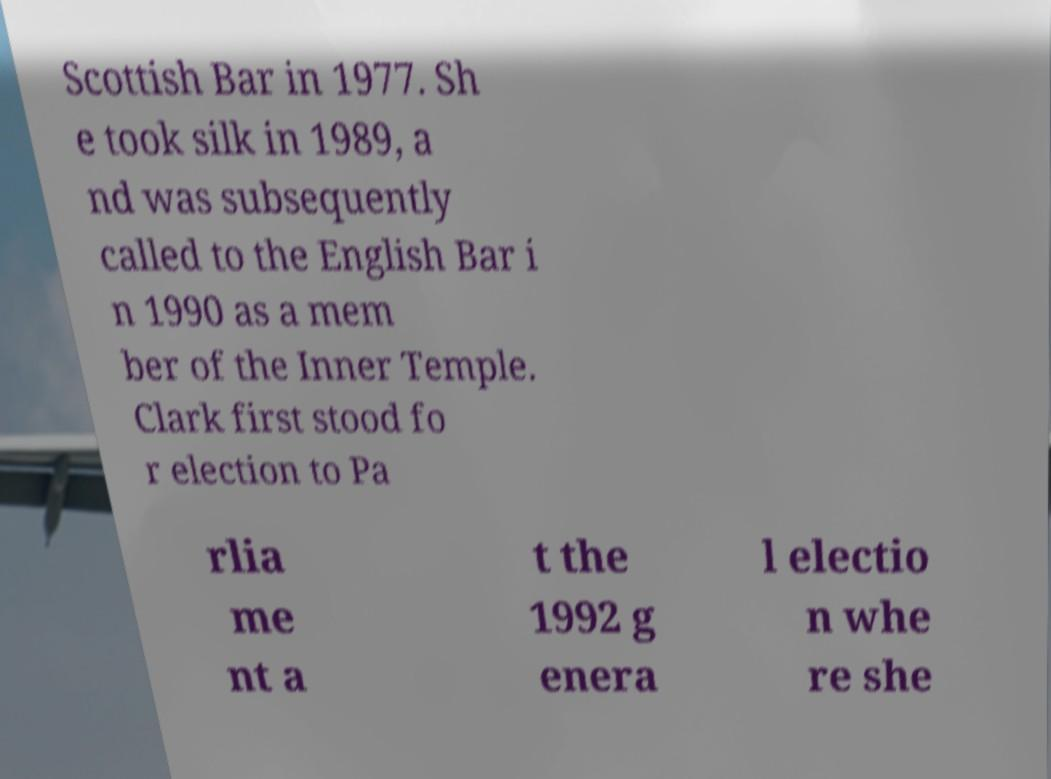Please identify and transcribe the text found in this image. Scottish Bar in 1977. Sh e took silk in 1989, a nd was subsequently called to the English Bar i n 1990 as a mem ber of the Inner Temple. Clark first stood fo r election to Pa rlia me nt a t the 1992 g enera l electio n whe re she 